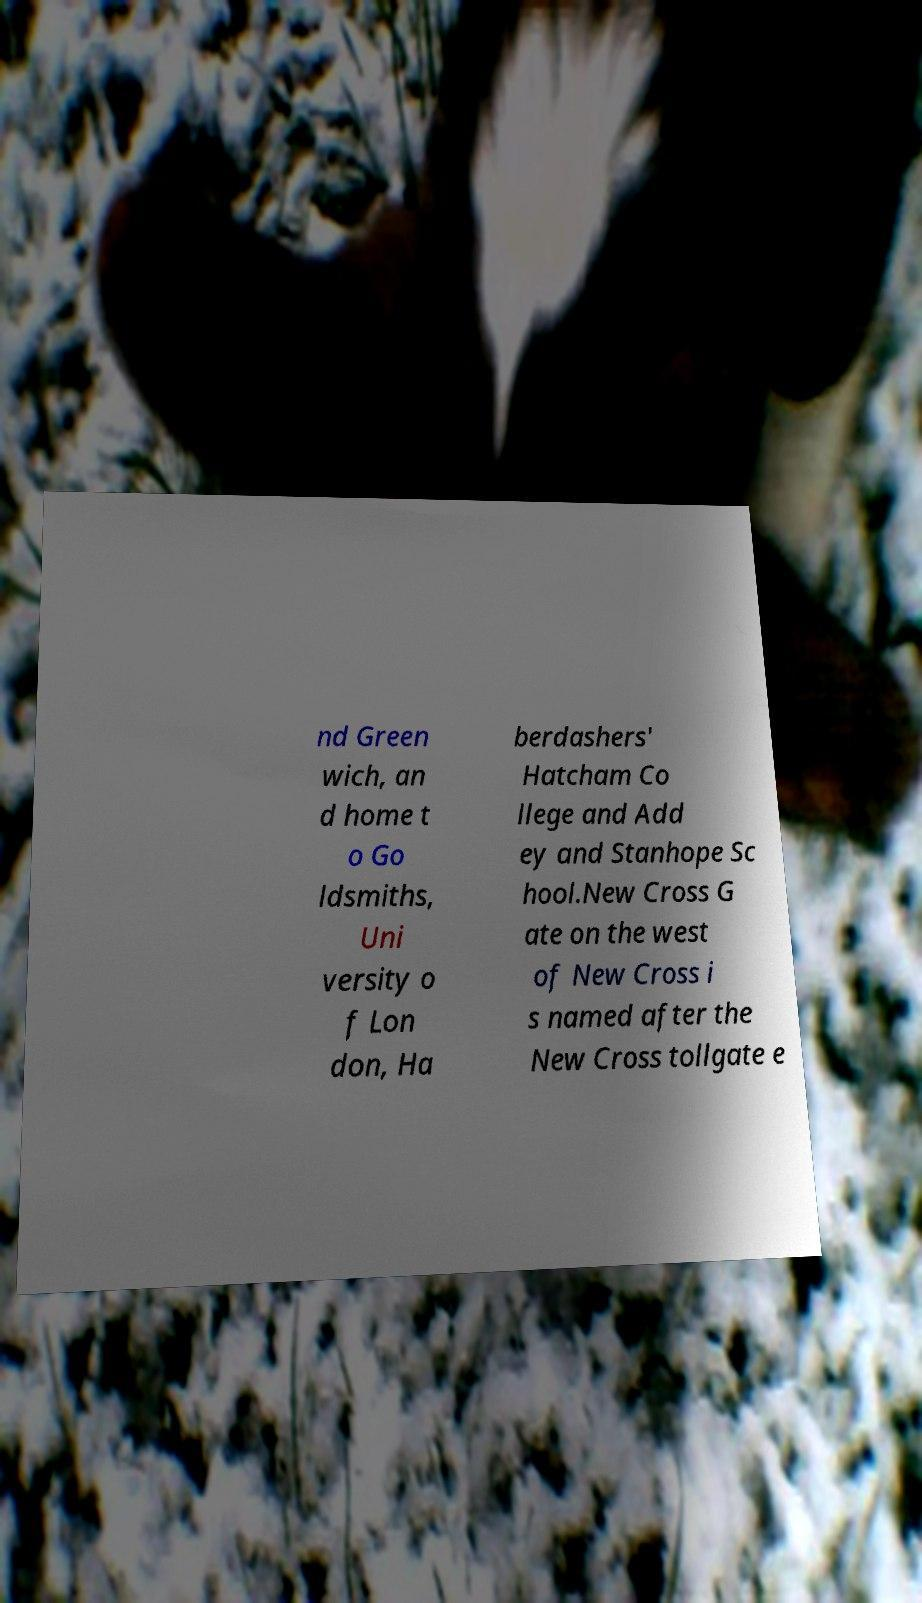What messages or text are displayed in this image? I need them in a readable, typed format. nd Green wich, an d home t o Go ldsmiths, Uni versity o f Lon don, Ha berdashers' Hatcham Co llege and Add ey and Stanhope Sc hool.New Cross G ate on the west of New Cross i s named after the New Cross tollgate e 